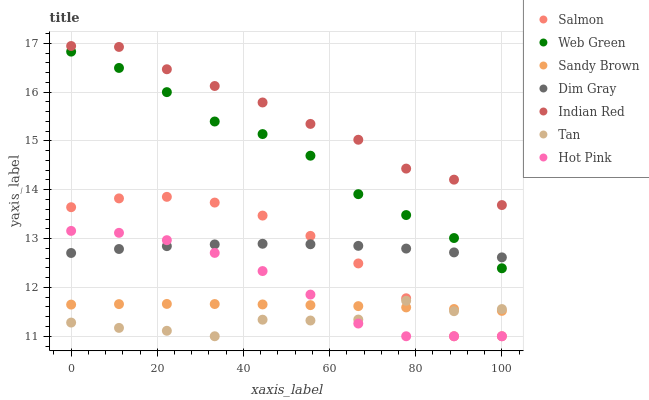Does Tan have the minimum area under the curve?
Answer yes or no. Yes. Does Indian Red have the maximum area under the curve?
Answer yes or no. Yes. Does Hot Pink have the minimum area under the curve?
Answer yes or no. No. Does Hot Pink have the maximum area under the curve?
Answer yes or no. No. Is Sandy Brown the smoothest?
Answer yes or no. Yes. Is Tan the roughest?
Answer yes or no. Yes. Is Hot Pink the smoothest?
Answer yes or no. No. Is Hot Pink the roughest?
Answer yes or no. No. Does Hot Pink have the lowest value?
Answer yes or no. Yes. Does Web Green have the lowest value?
Answer yes or no. No. Does Indian Red have the highest value?
Answer yes or no. Yes. Does Hot Pink have the highest value?
Answer yes or no. No. Is Tan less than Indian Red?
Answer yes or no. Yes. Is Web Green greater than Hot Pink?
Answer yes or no. Yes. Does Hot Pink intersect Tan?
Answer yes or no. Yes. Is Hot Pink less than Tan?
Answer yes or no. No. Is Hot Pink greater than Tan?
Answer yes or no. No. Does Tan intersect Indian Red?
Answer yes or no. No. 